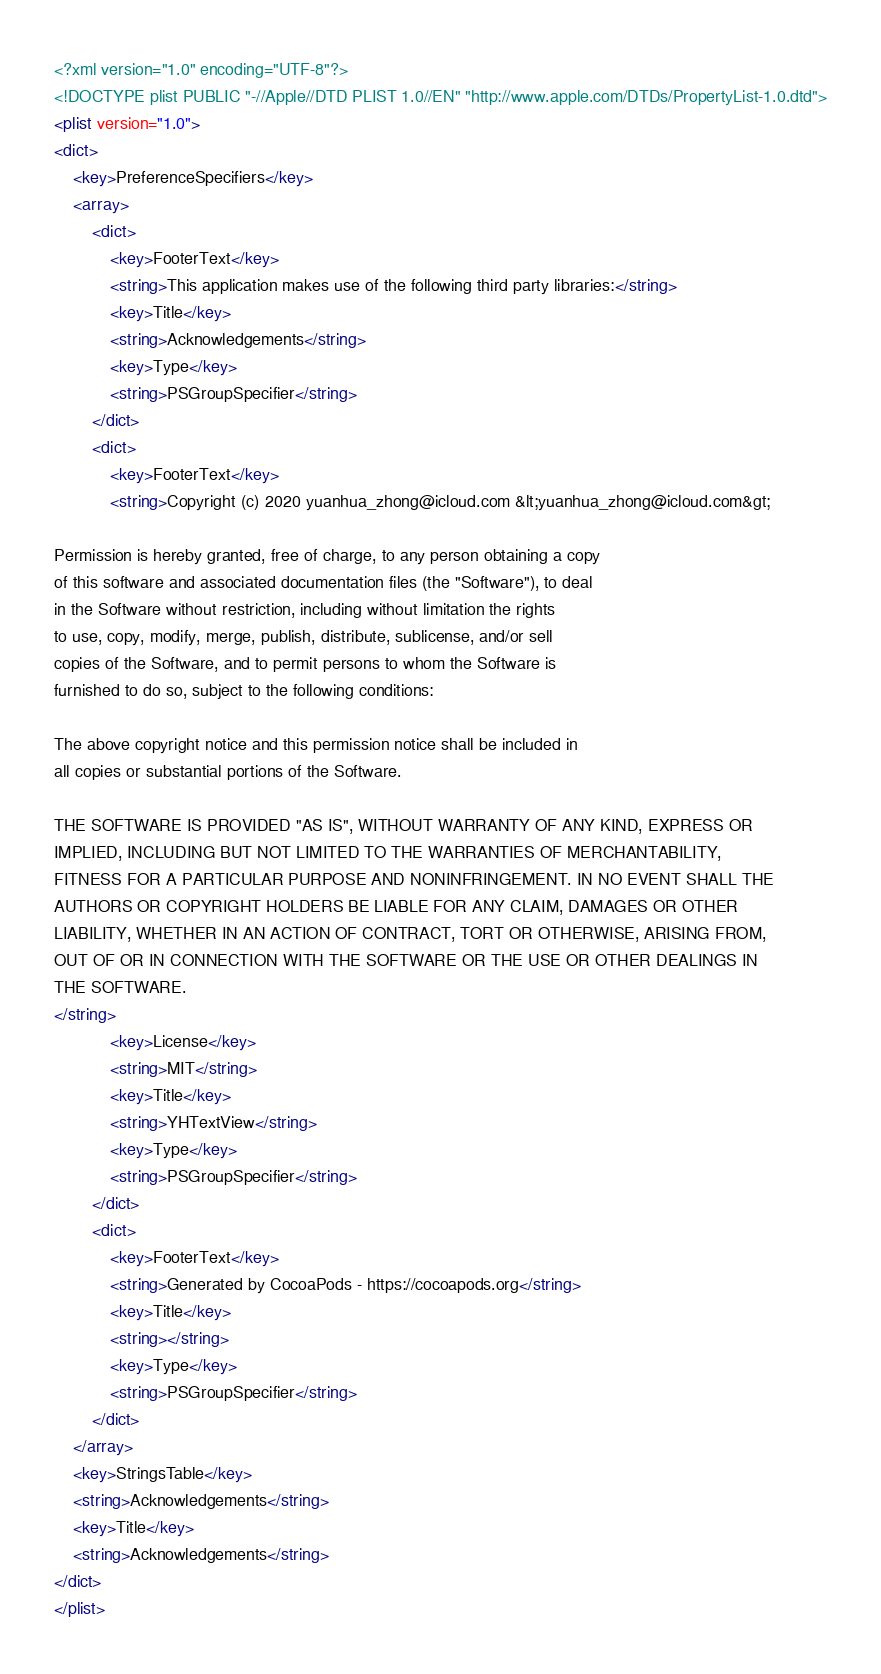Convert code to text. <code><loc_0><loc_0><loc_500><loc_500><_XML_><?xml version="1.0" encoding="UTF-8"?>
<!DOCTYPE plist PUBLIC "-//Apple//DTD PLIST 1.0//EN" "http://www.apple.com/DTDs/PropertyList-1.0.dtd">
<plist version="1.0">
<dict>
	<key>PreferenceSpecifiers</key>
	<array>
		<dict>
			<key>FooterText</key>
			<string>This application makes use of the following third party libraries:</string>
			<key>Title</key>
			<string>Acknowledgements</string>
			<key>Type</key>
			<string>PSGroupSpecifier</string>
		</dict>
		<dict>
			<key>FooterText</key>
			<string>Copyright (c) 2020 yuanhua_zhong@icloud.com &lt;yuanhua_zhong@icloud.com&gt;

Permission is hereby granted, free of charge, to any person obtaining a copy
of this software and associated documentation files (the "Software"), to deal
in the Software without restriction, including without limitation the rights
to use, copy, modify, merge, publish, distribute, sublicense, and/or sell
copies of the Software, and to permit persons to whom the Software is
furnished to do so, subject to the following conditions:

The above copyright notice and this permission notice shall be included in
all copies or substantial portions of the Software.

THE SOFTWARE IS PROVIDED "AS IS", WITHOUT WARRANTY OF ANY KIND, EXPRESS OR
IMPLIED, INCLUDING BUT NOT LIMITED TO THE WARRANTIES OF MERCHANTABILITY,
FITNESS FOR A PARTICULAR PURPOSE AND NONINFRINGEMENT. IN NO EVENT SHALL THE
AUTHORS OR COPYRIGHT HOLDERS BE LIABLE FOR ANY CLAIM, DAMAGES OR OTHER
LIABILITY, WHETHER IN AN ACTION OF CONTRACT, TORT OR OTHERWISE, ARISING FROM,
OUT OF OR IN CONNECTION WITH THE SOFTWARE OR THE USE OR OTHER DEALINGS IN
THE SOFTWARE.
</string>
			<key>License</key>
			<string>MIT</string>
			<key>Title</key>
			<string>YHTextView</string>
			<key>Type</key>
			<string>PSGroupSpecifier</string>
		</dict>
		<dict>
			<key>FooterText</key>
			<string>Generated by CocoaPods - https://cocoapods.org</string>
			<key>Title</key>
			<string></string>
			<key>Type</key>
			<string>PSGroupSpecifier</string>
		</dict>
	</array>
	<key>StringsTable</key>
	<string>Acknowledgements</string>
	<key>Title</key>
	<string>Acknowledgements</string>
</dict>
</plist>
</code> 